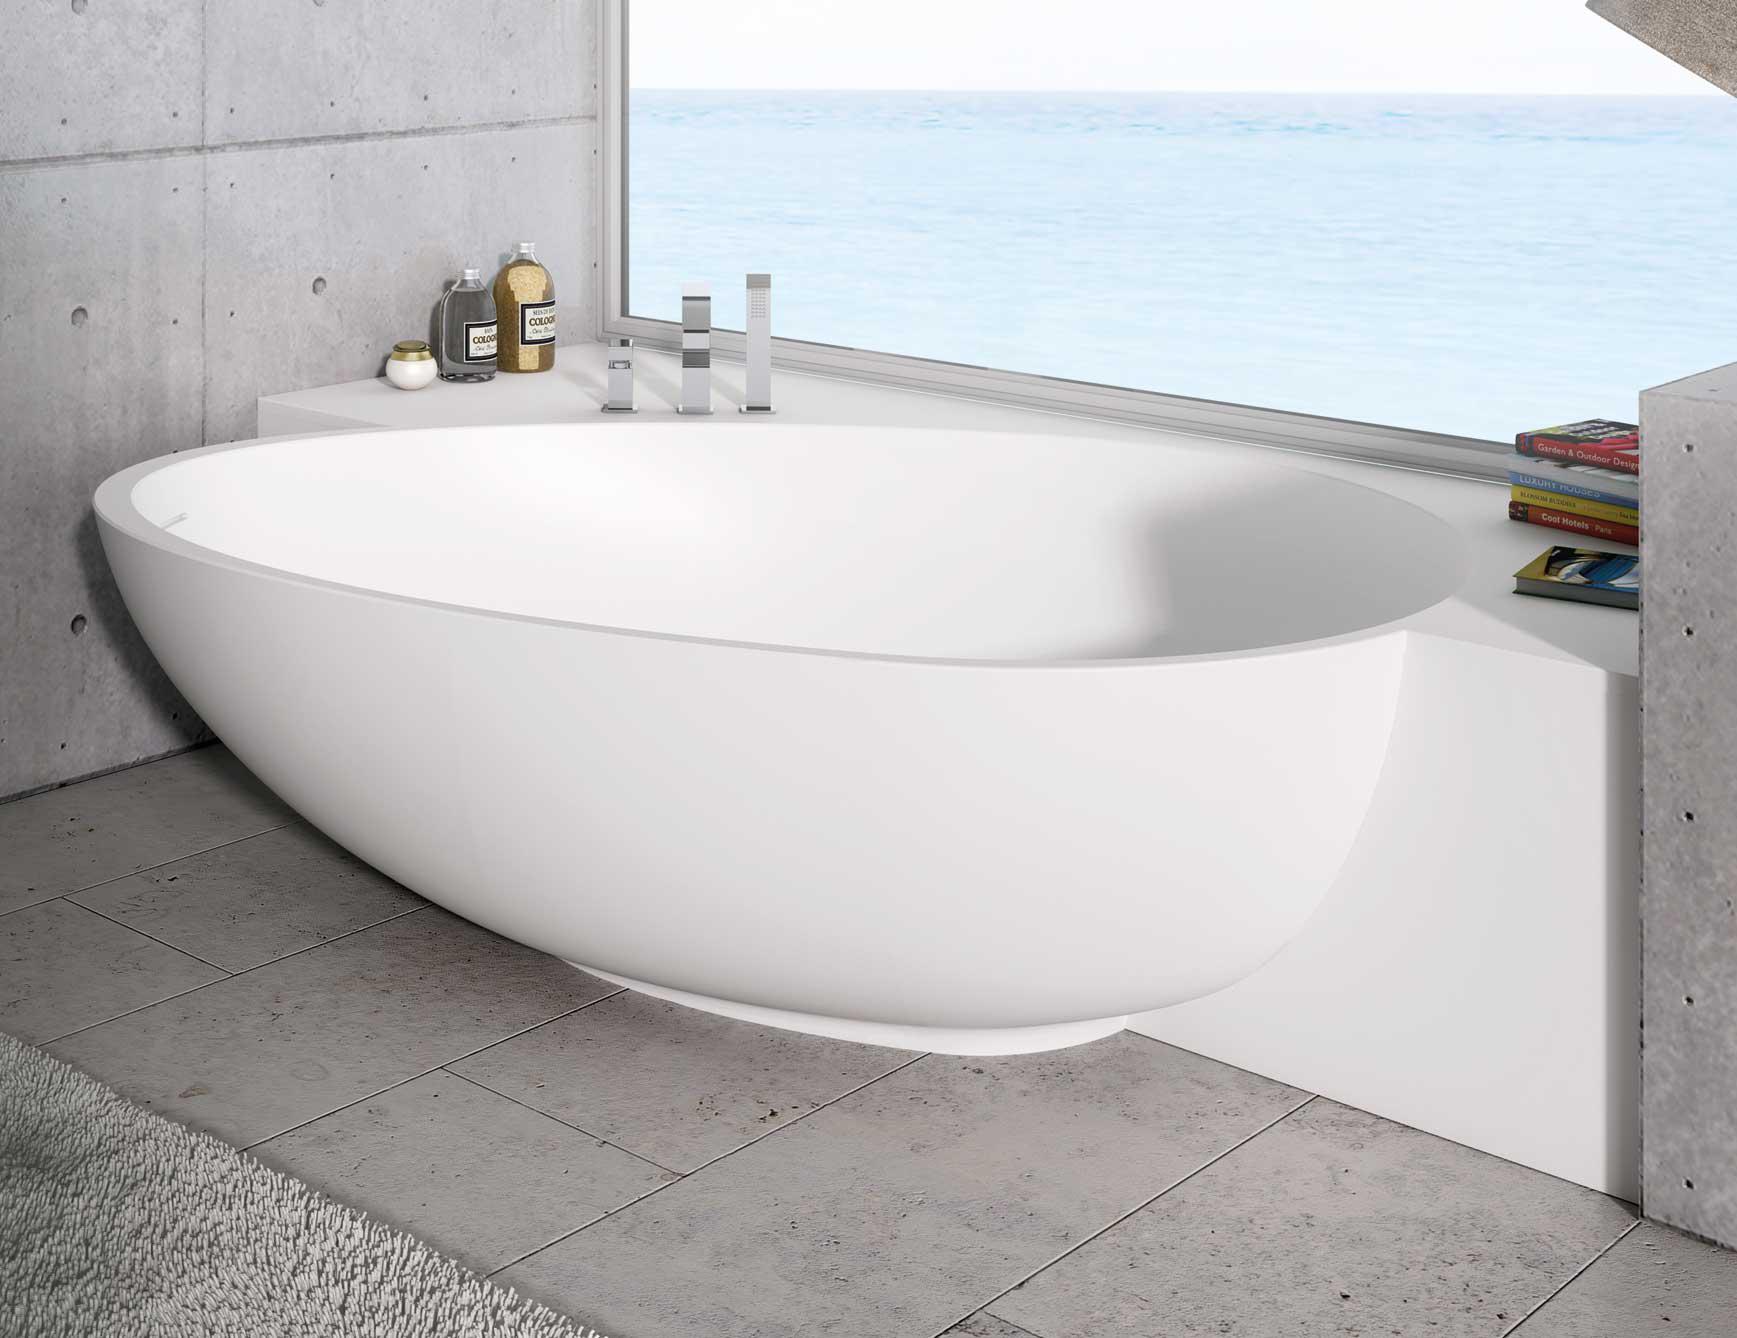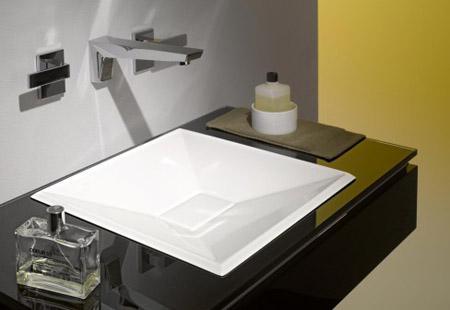The first image is the image on the left, the second image is the image on the right. Examine the images to the left and right. Is the description "One wash basin currently contains water." accurate? Answer yes or no. No. The first image is the image on the left, the second image is the image on the right. Analyze the images presented: Is the assertion "The sink on the right has a somewhat spiral shape and has a spout mounted on the wall above it, and the counter-top sink on the left is white and rounded with a silver spout over the basin." valid? Answer yes or no. No. 